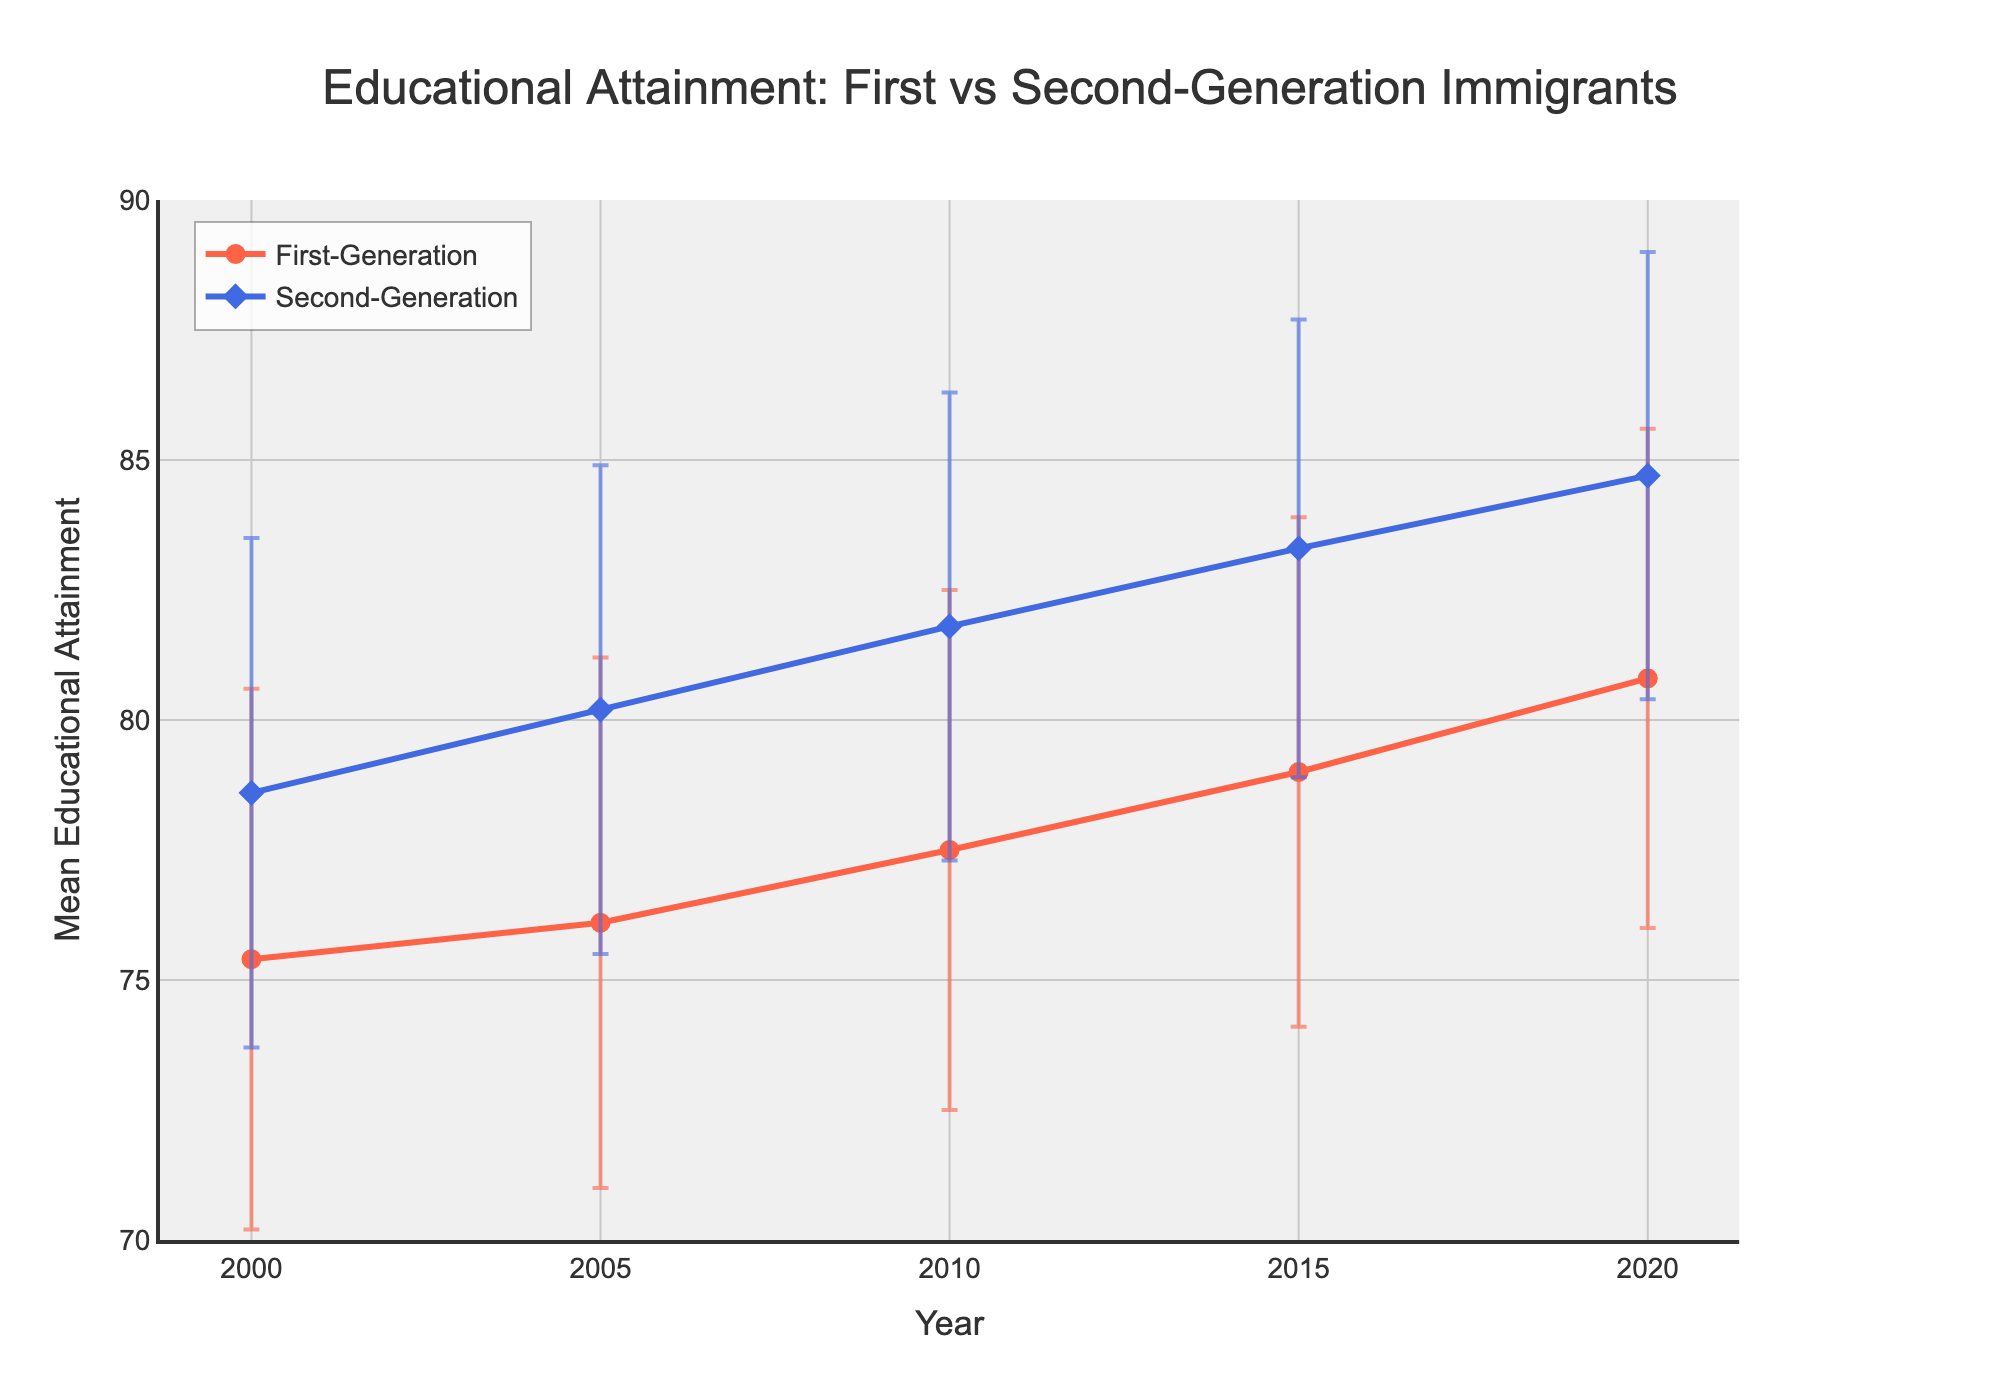What's the title of the figure? The title is displayed at the top center of the figure, and it reads 'Educational Attainment: First vs Second-Generation Immigrants'.
Answer: Educational Attainment: First vs Second-Generation Immigrants In what year did the second-generation immigrants have the highest mean educational attainment? The highest mean educational attainment for second-generation immigrants can be observed on the y-axis, and it occurs at the data point labeled '2020'.
Answer: 2020 What is the mean educational attainment difference between first-generation and second-generation immigrants in 2010? Locate the 2010 data points for both groups on the x-axis. The mean attainment for first-generation immigrants is 77.5, and for second-generation immigrants, it is 81.8. Subtract 77.5 from 81.8.
Answer: 4.3 Which group shows a greater increase in mean educational attainment from 2000 to 2020? By comparing the differences in mean educational attainment from 2000 to 2020 for both groups: First-generation increased from 75.4 to 80.8 (5.4) and second-generation from 78.6 to 84.7 (6.1). The second-generation shows a greater increase.
Answer: Second-Generation Between 2005 and 2015, which group exhibited the most consistent mean educational attainment (smallest standard deviation change)? For 2005, the standard deviations are 5.1 (First-Generation) and 4.7 (Second-Generation). For 2015, they are 4.9 (First-Generation) and 4.4 (Second-Generation). Calculate the standard deviation changes: 5.1-4.9=0.2 (First-Generation), 4.7-4.4=0.3 (Second-Generation). First-Generation has the smallest change.
Answer: First-Generation How does the mean educational attainment for first-generation immigrants change over the years? Trace the line from 2000 (75.4) to 2020 (80.8) and observe the changes at each plotted year: 2005 (76.1), 2010 (77.5), 2015 (79.0), 2020 (80.8). The trend shows a gradual increase over the period.
Answer: Gradual Increase In which year is the standard deviation of educational attainment for second-generation immigrants the lowest? Look at the error bars for second-generation immigrants and compare their lengths. The shortest error bar occurs in 2020, corresponding to the smallest standard deviation of 4.3.
Answer: 2020 By how much did the mean educational attainment for first-generation immigrants increase from 2015 to 2020? Find the mean attainment values for the first-generation group in 2015 (79.0) and 2020 (80.8). Subtract 79.0 from 80.8.
Answer: 1.8 Which group had the higher mean educational attainment in 2000, and by how much? Compare the values for both groups in 2000: First-Generation is 75.4, and Second-Generation is 78.6. Subtract 75.4 from 78.6 to find the difference.
Answer: Second-Generation, by 3.2 